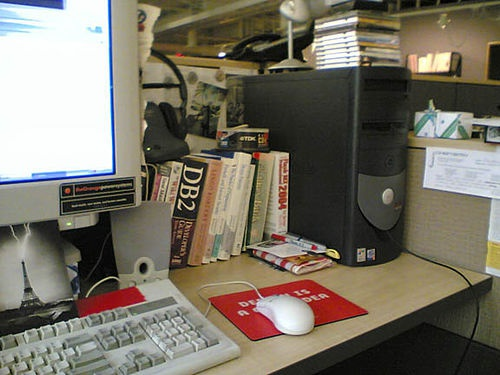Describe the objects in this image and their specific colors. I can see tv in darkblue, white, darkgray, gray, and black tones, keyboard in darkblue, darkgray, and gray tones, book in darkblue, black, maroon, and gray tones, book in darkblue, darkgray, tan, gray, and black tones, and book in darkblue, tan, and gray tones in this image. 